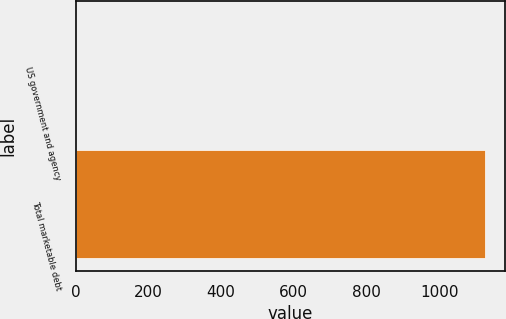Convert chart. <chart><loc_0><loc_0><loc_500><loc_500><bar_chart><fcel>US government and agency<fcel>Total marketable debt<nl><fcel>0.6<fcel>1125.5<nl></chart> 